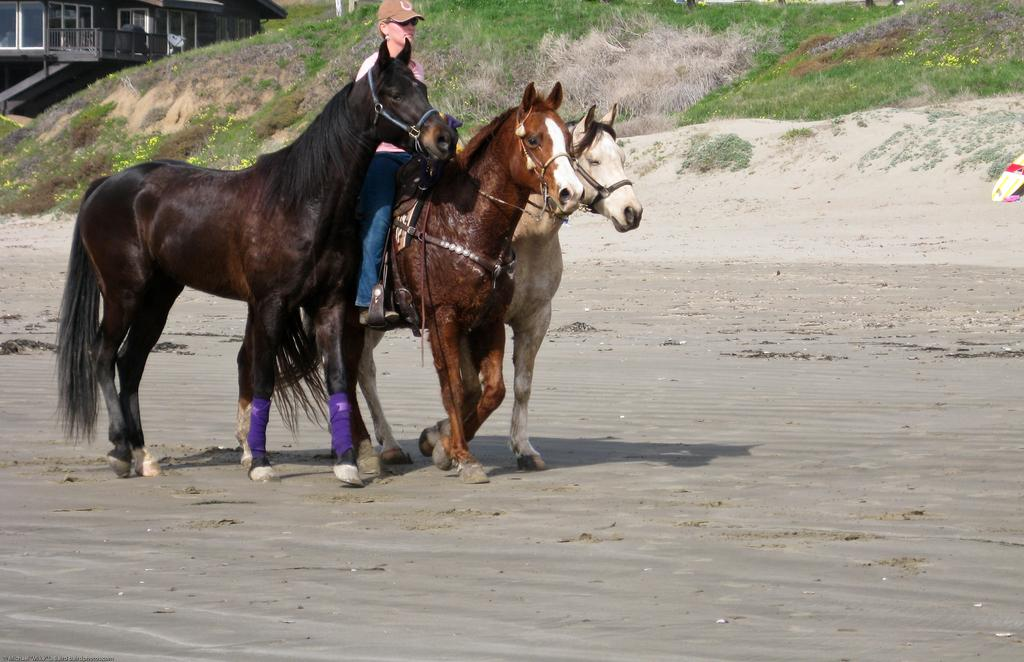How many horses are in the image? There are three horses in the image. What are the horses doing in the image? The horses are walking on the sand. What type of terrain is visible behind the horses? There is a lot of grass behind the horses. What structure can be seen on the left side of the image? There is a house on the left side of the image. What type of body is the donkey using to balance itself in the image? There is no donkey present in the image, so it is not possible to answer that question. 